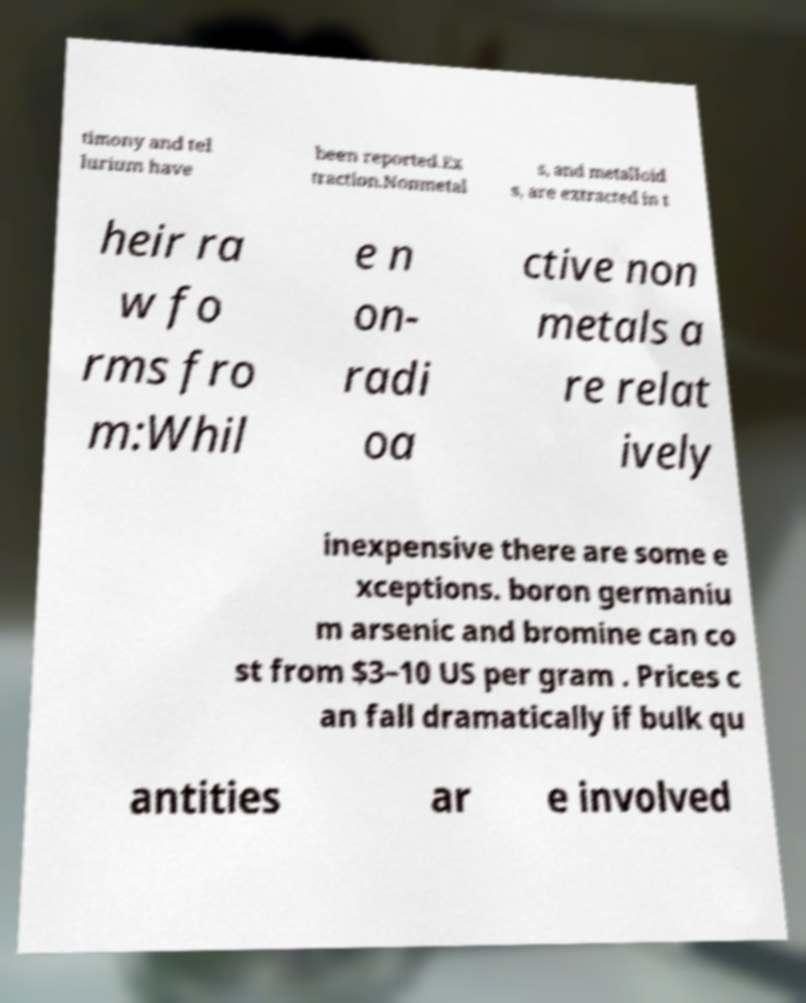Could you assist in decoding the text presented in this image and type it out clearly? timony and tel lurium have been reported.Ex traction.Nonmetal s, and metalloid s, are extracted in t heir ra w fo rms fro m:Whil e n on- radi oa ctive non metals a re relat ively inexpensive there are some e xceptions. boron germaniu m arsenic and bromine can co st from $3–10 US per gram . Prices c an fall dramatically if bulk qu antities ar e involved 